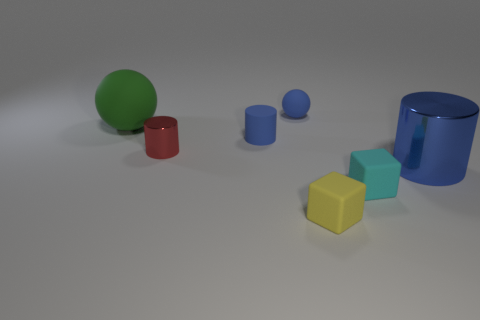Add 3 brown rubber balls. How many objects exist? 10 Subtract all matte cylinders. How many cylinders are left? 2 Subtract all cyan cubes. How many blue cylinders are left? 2 Subtract all blue cylinders. How many cylinders are left? 1 Subtract all blocks. How many objects are left? 5 Subtract 1 balls. How many balls are left? 1 Subtract all green cylinders. Subtract all purple balls. How many cylinders are left? 3 Subtract all small cyan rubber blocks. Subtract all large brown shiny balls. How many objects are left? 6 Add 4 tiny blue cylinders. How many tiny blue cylinders are left? 5 Add 2 blue spheres. How many blue spheres exist? 3 